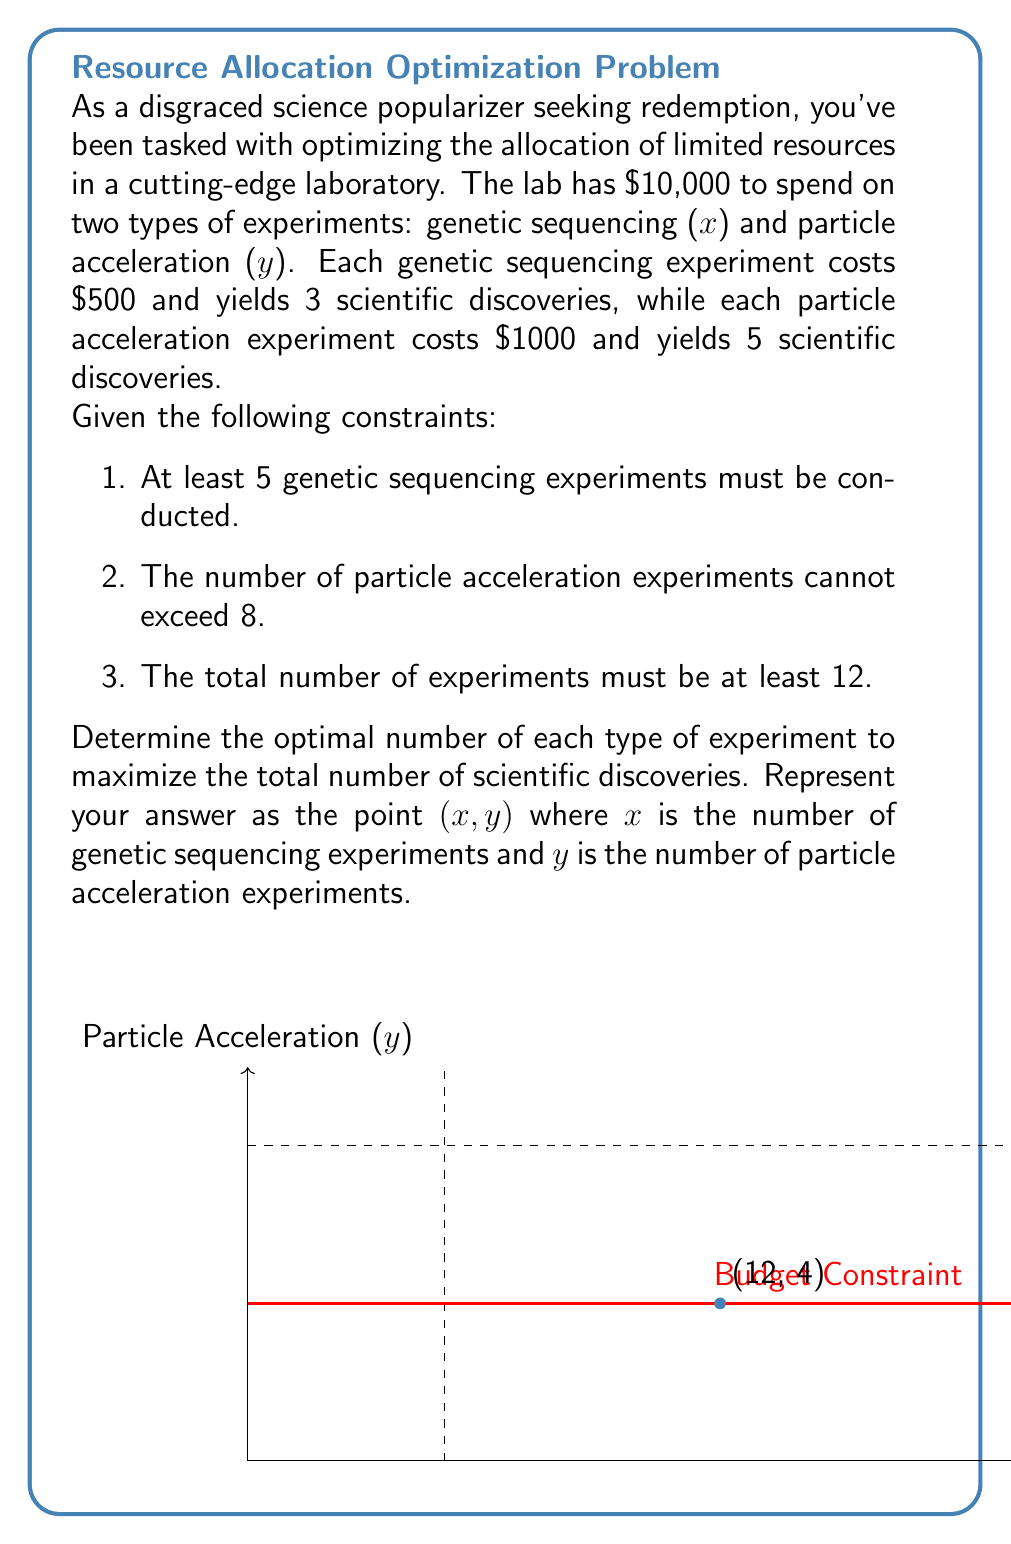Help me with this question. Let's approach this step-by-step using linear programming:

1) Define the objective function:
   Maximize $Z = 3x + 5y$ (total scientific discoveries)

2) List the constraints:
   a) $500x + 1000y \leq 10000$ (budget constraint)
   b) $x \geq 5$ (minimum genetic sequencing experiments)
   c) $y \leq 8$ (maximum particle acceleration experiments)
   d) $x + y \geq 12$ (minimum total experiments)
   e) $x, y \geq 0$ and integer (non-negativity and integer constraints)

3) Simplify the budget constraint:
   $500x + 1000y \leq 10000$
   $x + 2y \leq 20$

4) Plot the feasible region:
   - The budget line is $x + 2y = 20$
   - The vertical line $x = 5$ represents the minimum genetic sequencing experiments
   - The horizontal line $y = 8$ represents the maximum particle acceleration experiments
   - The line $x + y = 12$ represents the minimum total experiments

5) Identify the corner points of the feasible region:
   (5, 7.5), (5, 8), (12, 4), (20, 0)

6) Evaluate the objective function at each integer point:
   (5, 8): $Z = 3(5) + 5(8) = 55$
   (12, 4): $Z = 3(12) + 5(4) = 56$

7) The maximum value occurs at (12, 4), which satisfies all constraints.

Therefore, the optimal solution is to conduct 12 genetic sequencing experiments and 4 particle acceleration experiments.
Answer: (12, 4) 